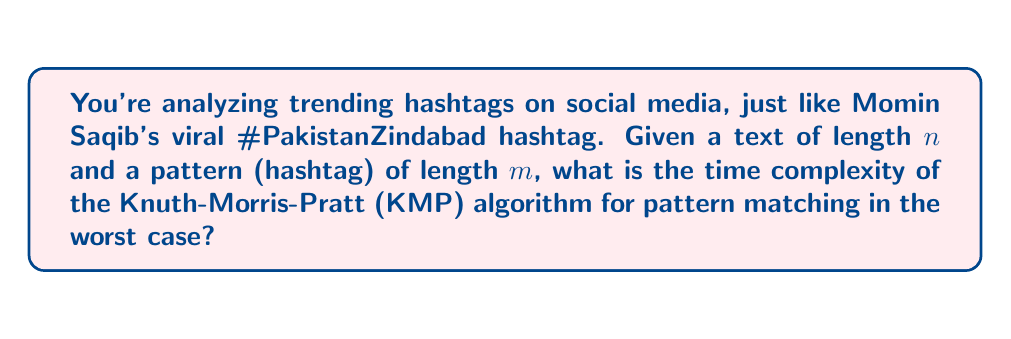Could you help me with this problem? To solve this problem, let's break down the Knuth-Morris-Pratt (KMP) algorithm and analyze its time complexity:

1. Preprocessing phase:
   - The KMP algorithm first constructs a failure function (also called the prefix function) for the pattern.
   - This step takes $O(m)$ time, where $m$ is the length of the pattern (hashtag).

2. Matching phase:
   - The algorithm then scans the text once, comparing it with the pattern.
   - In the worst case, it performs $O(n)$ comparisons, where $n$ is the length of the text.

3. Total time complexity:
   - The total time is the sum of the preprocessing and matching phases.
   - Thus, the total time complexity is $O(m) + O(n) = O(m + n)$.

4. Worst-case scenario:
   - In the worst case, when the pattern doesn't match the text at all, or matches only at the very end, the algorithm will still perform $O(n)$ comparisons.
   - The preprocessing step always takes $O(m)$ time.

5. Simplification:
   - Since $m \leq n$ (the pattern length is typically smaller than or equal to the text length), we can simplify the complexity to $O(n)$.

Therefore, the worst-case time complexity of the KMP algorithm for pattern matching is $O(n)$, where $n$ is the length of the text being searched.
Answer: $O(n)$ 